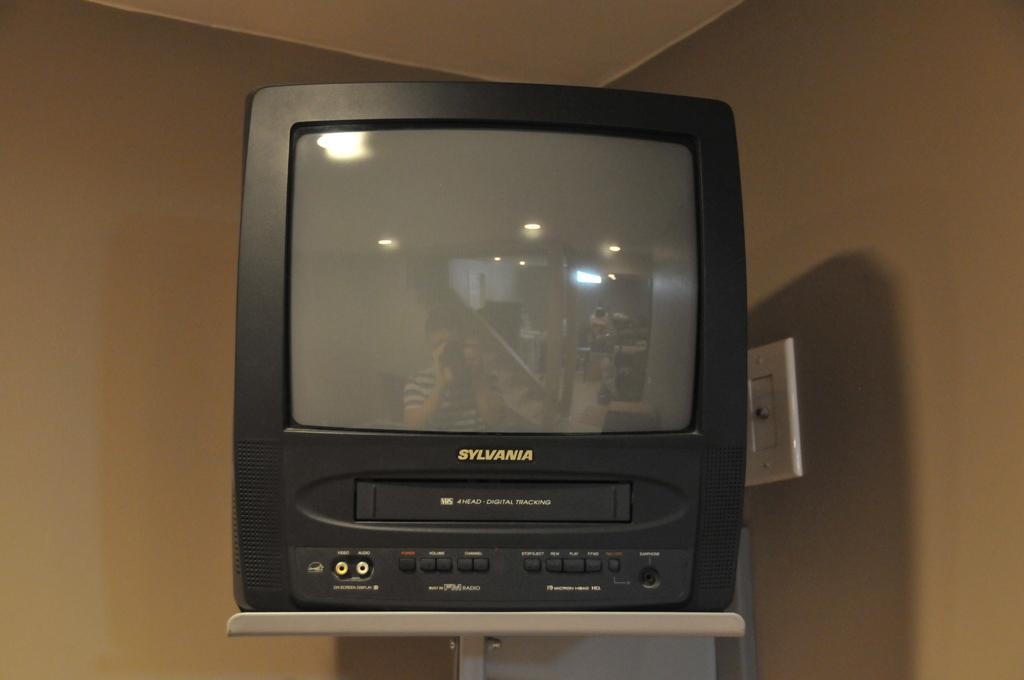<image>
Offer a succinct explanation of the picture presented. a Sylvania TV set standing on a stand 